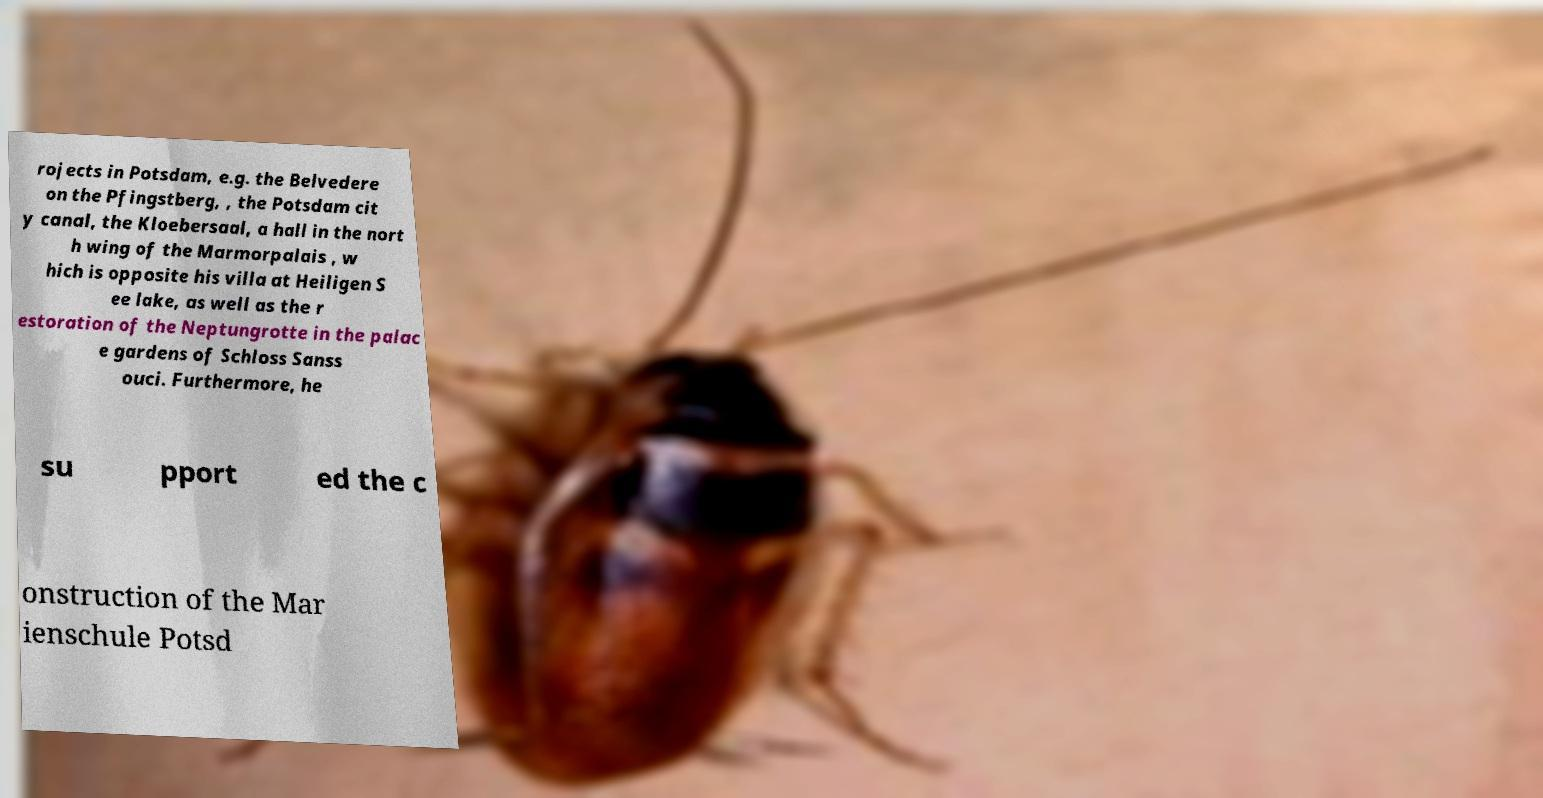Please identify and transcribe the text found in this image. rojects in Potsdam, e.g. the Belvedere on the Pfingstberg, , the Potsdam cit y canal, the Kloebersaal, a hall in the nort h wing of the Marmorpalais , w hich is opposite his villa at Heiligen S ee lake, as well as the r estoration of the Neptungrotte in the palac e gardens of Schloss Sanss ouci. Furthermore, he su pport ed the c onstruction of the Mar ienschule Potsd 